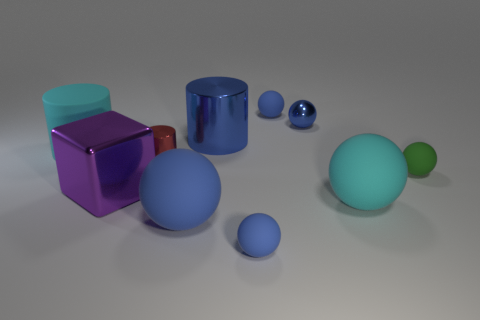Subtract all blue balls. How many were subtracted if there are2blue balls left? 2 Subtract all small metal balls. How many balls are left? 5 Subtract all blue cylinders. How many cylinders are left? 2 Subtract all blocks. How many objects are left? 9 Subtract 5 balls. How many balls are left? 1 Subtract all purple spheres. Subtract all gray cubes. How many spheres are left? 6 Subtract all blue cubes. How many cyan balls are left? 1 Subtract all large blue things. Subtract all small matte objects. How many objects are left? 5 Add 6 big cyan things. How many big cyan things are left? 8 Add 9 brown matte blocks. How many brown matte blocks exist? 9 